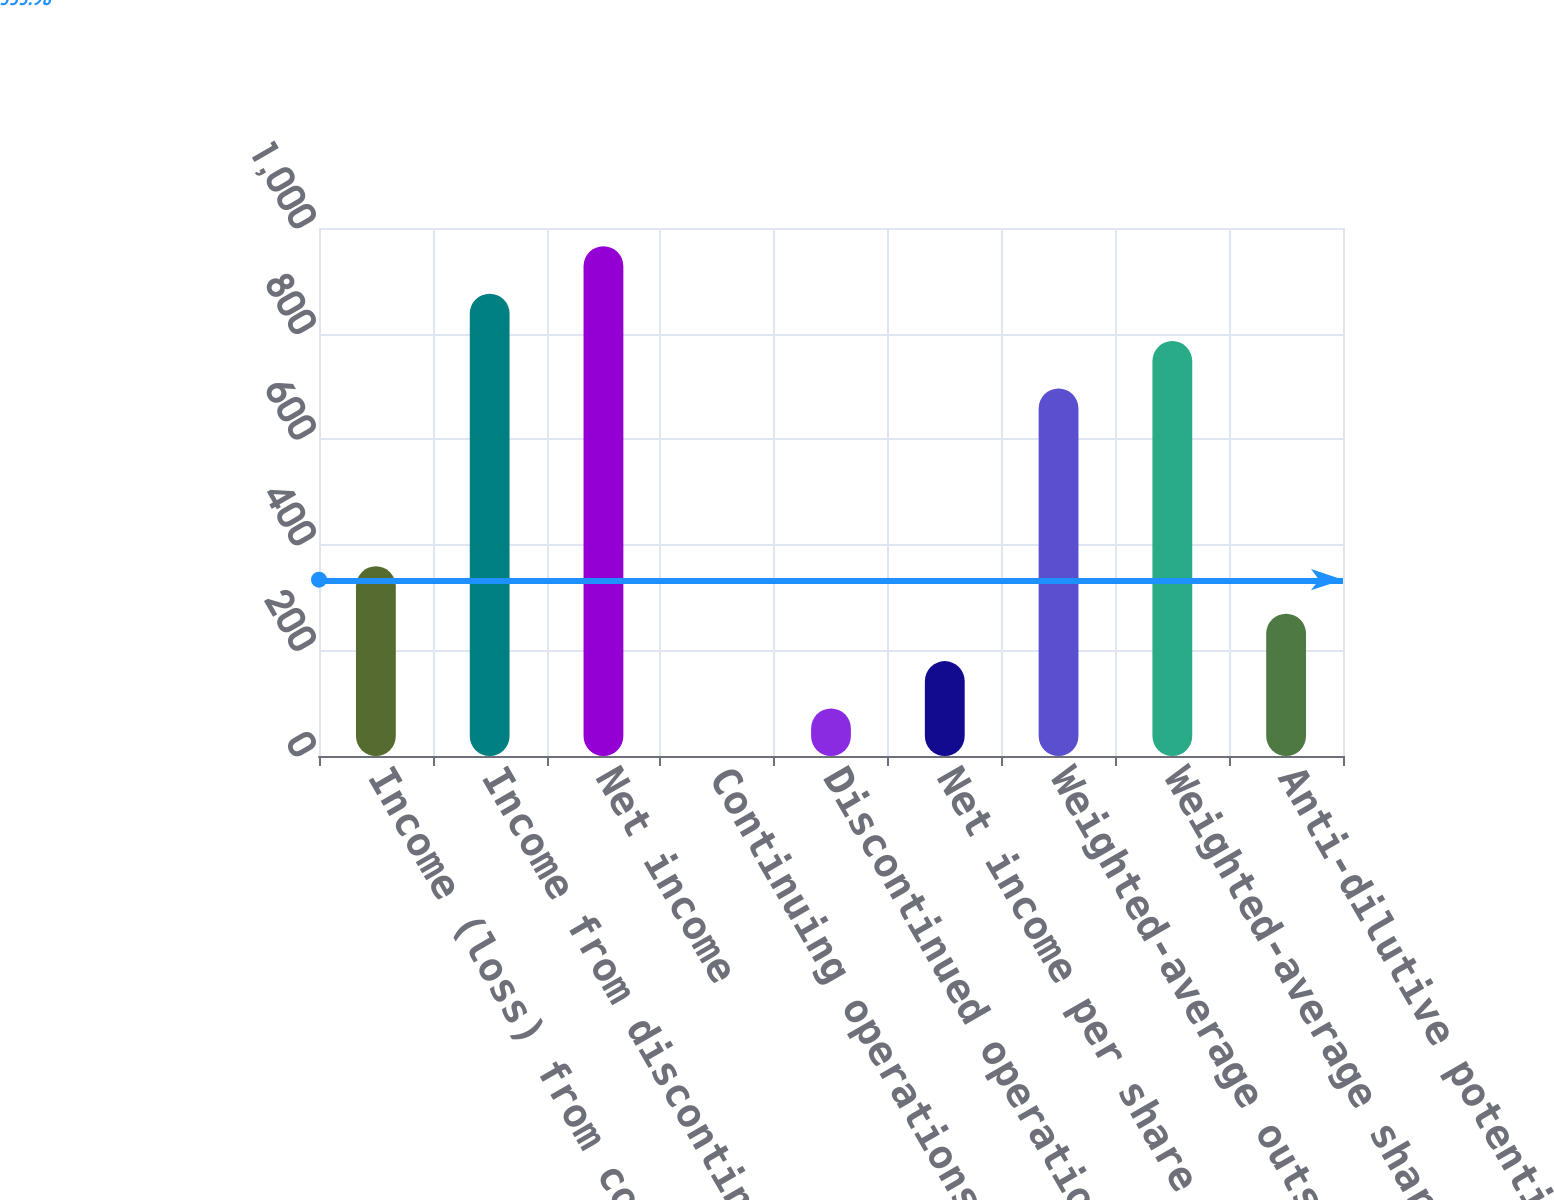<chart> <loc_0><loc_0><loc_500><loc_500><bar_chart><fcel>Income (loss) from continuing<fcel>Income from discontinued<fcel>Net income<fcel>Continuing operations<fcel>Discontinued operations<fcel>Net income per share<fcel>Weighted-average outstanding<fcel>Weighted-average shares<fcel>Anti-dilutive potential shares<nl><fcel>359.29<fcel>875.58<fcel>965.37<fcel>0.13<fcel>89.92<fcel>179.71<fcel>696<fcel>785.79<fcel>269.5<nl></chart> 